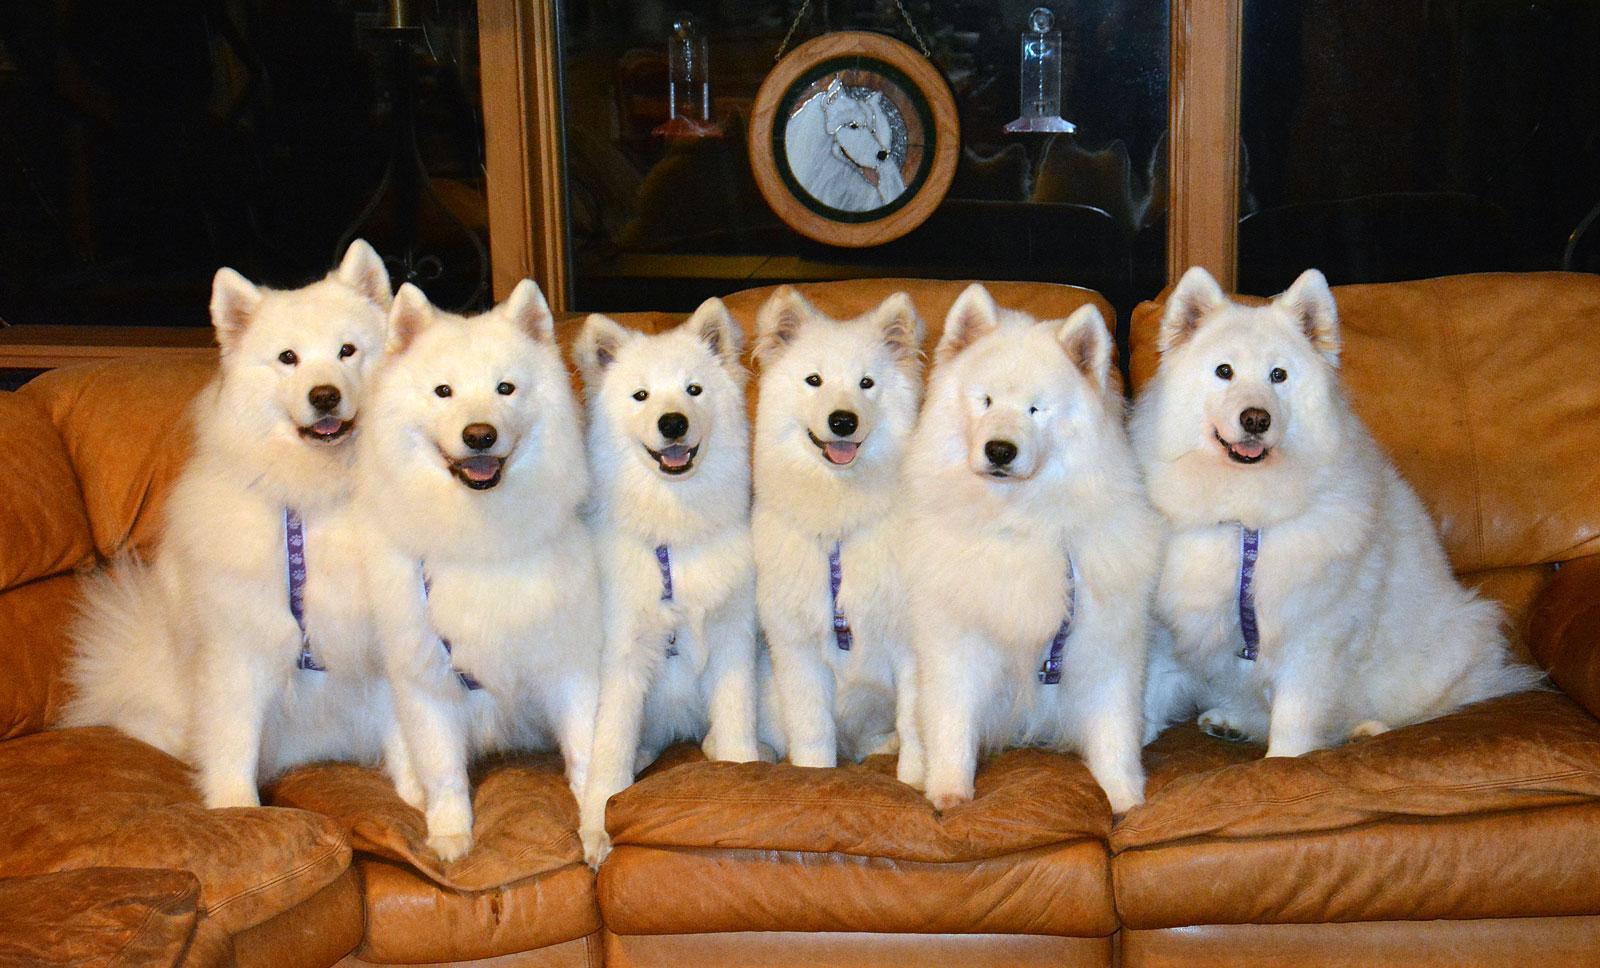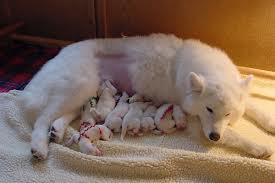The first image is the image on the left, the second image is the image on the right. Given the left and right images, does the statement "a dog is indoors on a wooden floor" hold true? Answer yes or no. No. The first image is the image on the left, the second image is the image on the right. For the images shown, is this caption "A dog is on a wooden floor." true? Answer yes or no. No. 